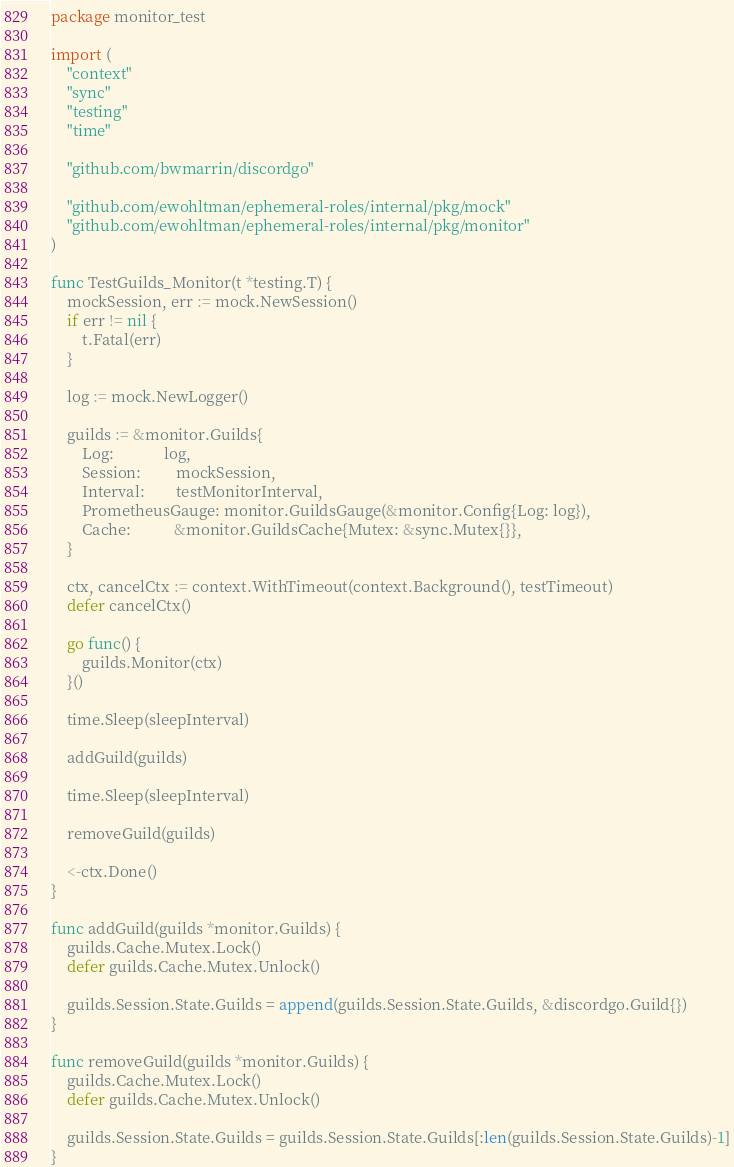<code> <loc_0><loc_0><loc_500><loc_500><_Go_>package monitor_test

import (
	"context"
	"sync"
	"testing"
	"time"

	"github.com/bwmarrin/discordgo"

	"github.com/ewohltman/ephemeral-roles/internal/pkg/mock"
	"github.com/ewohltman/ephemeral-roles/internal/pkg/monitor"
)

func TestGuilds_Monitor(t *testing.T) {
	mockSession, err := mock.NewSession()
	if err != nil {
		t.Fatal(err)
	}

	log := mock.NewLogger()

	guilds := &monitor.Guilds{
		Log:             log,
		Session:         mockSession,
		Interval:        testMonitorInterval,
		PrometheusGauge: monitor.GuildsGauge(&monitor.Config{Log: log}),
		Cache:           &monitor.GuildsCache{Mutex: &sync.Mutex{}},
	}

	ctx, cancelCtx := context.WithTimeout(context.Background(), testTimeout)
	defer cancelCtx()

	go func() {
		guilds.Monitor(ctx)
	}()

	time.Sleep(sleepInterval)

	addGuild(guilds)

	time.Sleep(sleepInterval)

	removeGuild(guilds)

	<-ctx.Done()
}

func addGuild(guilds *monitor.Guilds) {
	guilds.Cache.Mutex.Lock()
	defer guilds.Cache.Mutex.Unlock()

	guilds.Session.State.Guilds = append(guilds.Session.State.Guilds, &discordgo.Guild{})
}

func removeGuild(guilds *monitor.Guilds) {
	guilds.Cache.Mutex.Lock()
	defer guilds.Cache.Mutex.Unlock()

	guilds.Session.State.Guilds = guilds.Session.State.Guilds[:len(guilds.Session.State.Guilds)-1]
}
</code> 